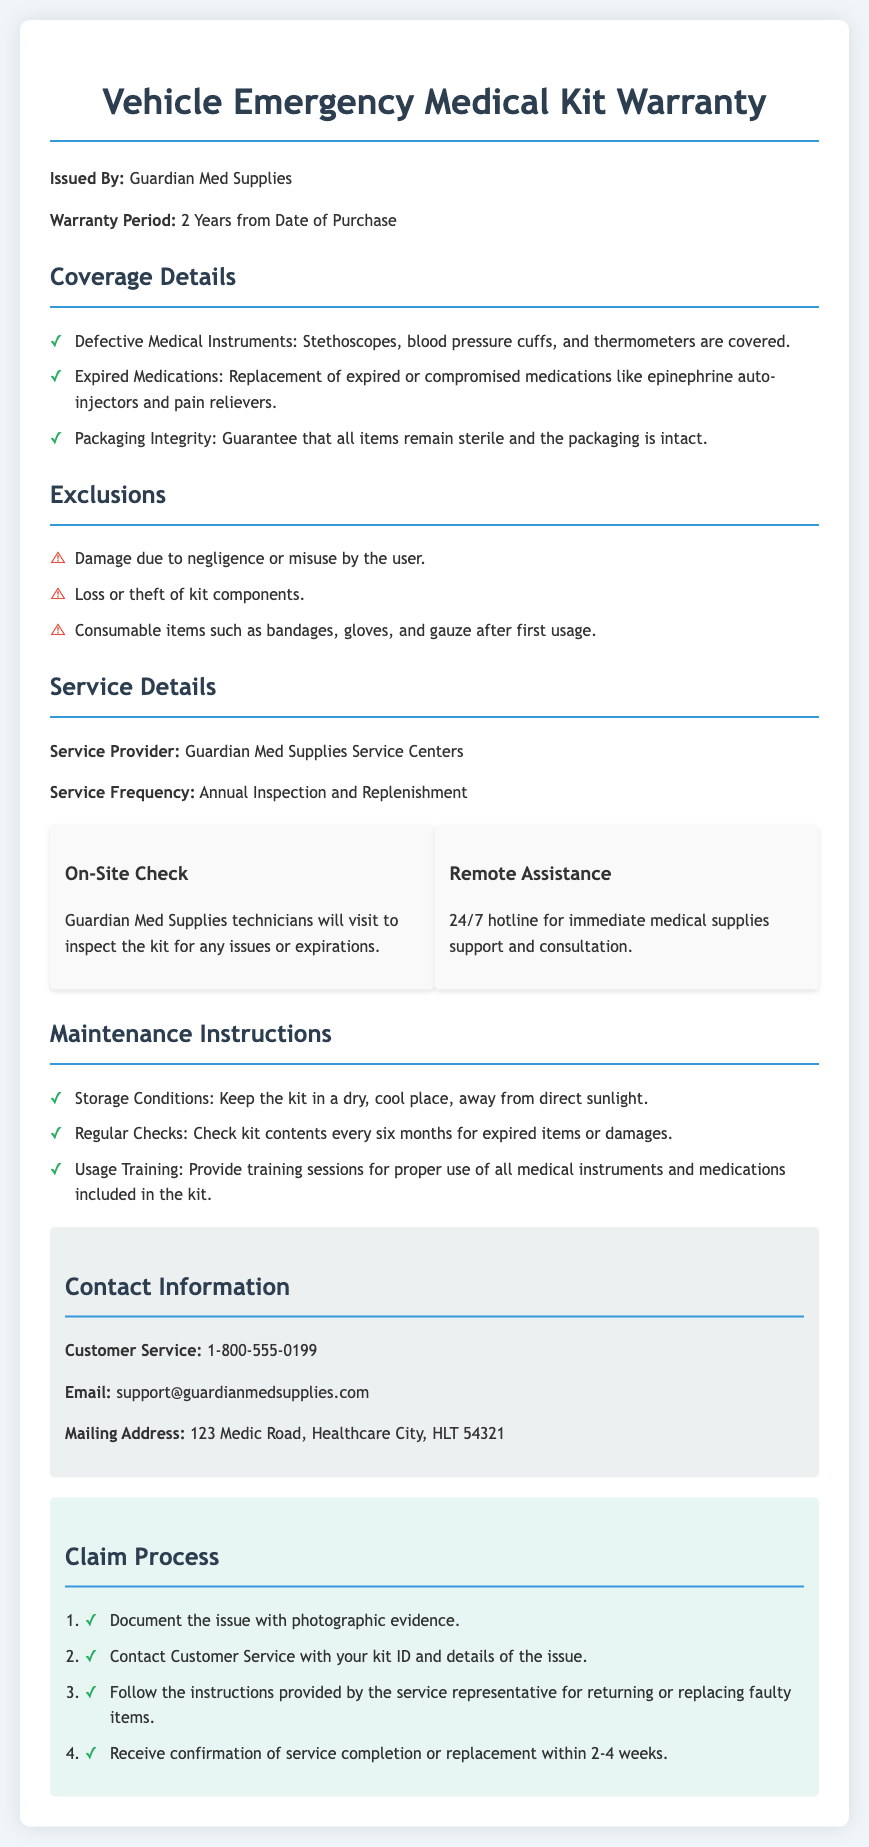What is the warranty period? The warranty period is specified directly in the document and is stated as 2 years from the date of purchase.
Answer: 2 Years Who issued the warranty? The issuer of the warranty is clearly mentioned at the beginning of the document as Guardian Med Supplies.
Answer: Guardian Med Supplies What items are covered under defective medical instruments? The document specifies that Stethoscopes, blood pressure cuffs, and thermometers are covered under defective medical instruments.
Answer: Stethoscopes, blood pressure cuffs, and thermometers What should be done every six months? The maintenance instructions mention that regular checks for expired items or damages should be conducted every six months.
Answer: Check kit contents How long will it take to receive confirmation of service completion or replacement? The document states that confirmation of service completion or replacement will be received within 2-4 weeks.
Answer: 2-4 weeks What is one of the exclusions mentioned in the warranty? The document lists damage due to negligence or misuse by the user as one of the exclusions.
Answer: Damage due to negligence What services are provided during the service frequency? According to the document, the service frequency involves an annual inspection and replenishment of the kit.
Answer: Annual Inspection and Replenishment What type of training is suggested in the maintenance instructions? The maintenance instructions suggest providing training sessions for proper use of all medical instruments and medications included in the kit.
Answer: Usage Training What is the customer service phone number? The document provides the customer service phone number clearly as 1-800-555-0199.
Answer: 1-800-555-0199 